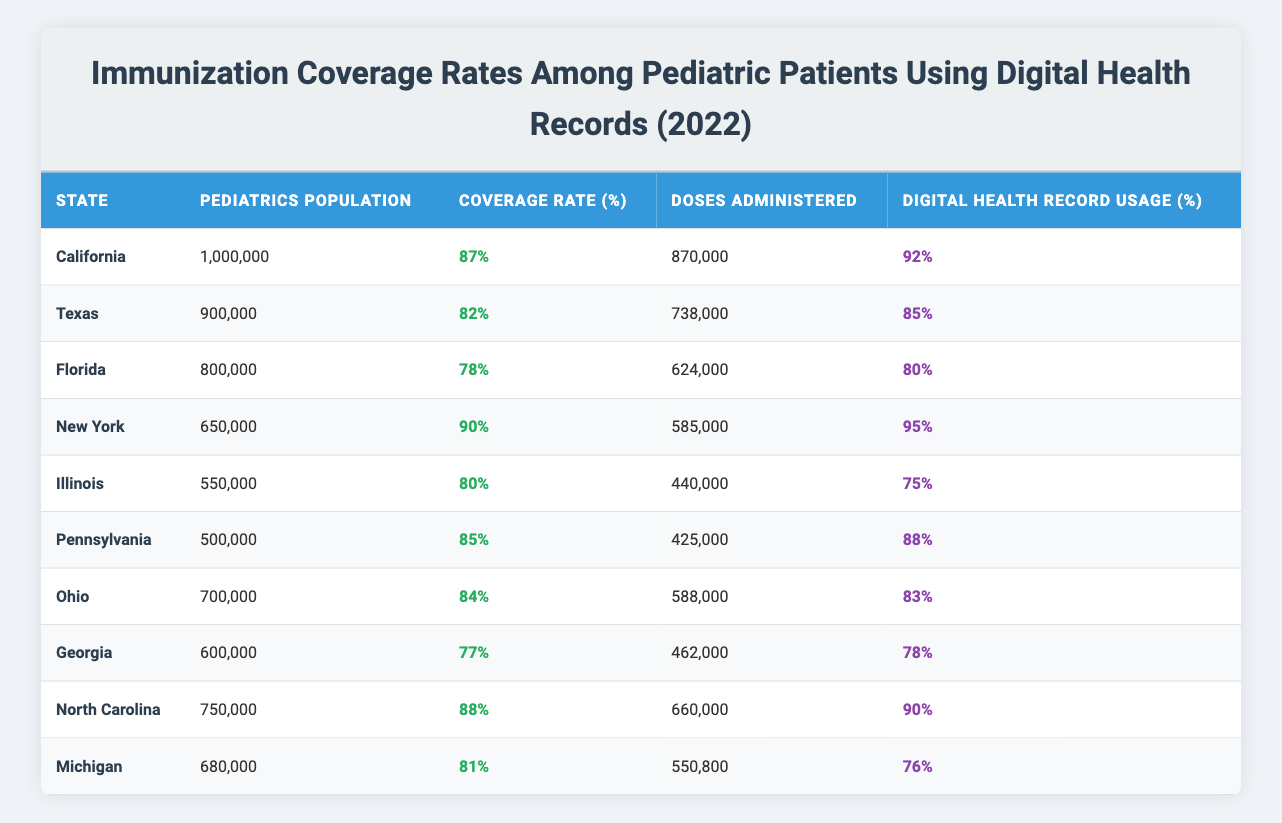What is the immunization coverage rate in California? The table lists California's coverage rate as 87%.
Answer: 87% Which state has the highest coverage rate? Looking at the coverage rates, New York has the highest at 90%.
Answer: New York How many doses were administered in Texas? The table shows that Texas administered 738,000 doses.
Answer: 738,000 What percentage of digital health records was used in Ohio? The digital health record usage for Ohio is listed as 83%.
Answer: 83% What is the average immunization coverage rate for all states listed? The coverage rates for all states add up to 825% (87+82+78+90+80+85+84+77+88+81) and there are 10 states, so the average is 825/10 = 82.5%.
Answer: 82.5% Which state has the lowest pediatric population? Illinois has the lowest pediatric population with 550,000.
Answer: Illinois Is the digital health record usage higher in states with higher coverage rates? Analyzing the coverage rates against digital health record usage shows some correlation, but not a strict rule; for instance, Florida has lower usage at 80% with a lower coverage rate of 78%.
Answer: No What is the difference in doses administered between California and Georgia? California administered 870,000 doses, while Georgia administered 462,000 doses. The difference is 870,000 - 462,000 = 408,000.
Answer: 408,000 How does North Carolina's coverage rate compare to Texas's? North Carolina has an 88% coverage rate, while Texas has 82%. Comparing these shows North Carolina's coverage is 6% higher than Texas's.
Answer: 6% higher If you combine the pediatric populations of Florida and Illinois, what is the total population? Florida's population is 800,000 and Illinois's is 550,000. The combined population is 800,000 + 550,000 = 1,350,000.
Answer: 1,350,000 